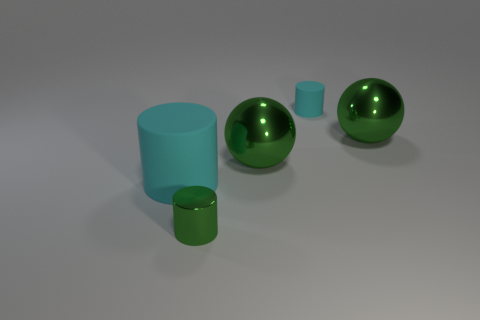How many cyan cylinders must be subtracted to get 1 cyan cylinders? 1 Add 1 small blocks. How many objects exist? 6 Subtract 0 blue cylinders. How many objects are left? 5 Subtract all cylinders. How many objects are left? 2 Subtract all green cylinders. Subtract all tiny green metallic objects. How many objects are left? 3 Add 1 green metal cylinders. How many green metal cylinders are left? 2 Add 1 cyan matte cylinders. How many cyan matte cylinders exist? 3 